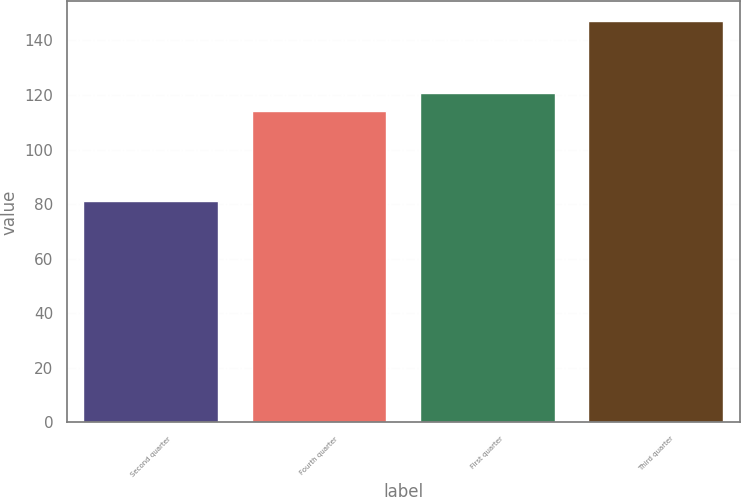<chart> <loc_0><loc_0><loc_500><loc_500><bar_chart><fcel>Second quarter<fcel>Fourth quarter<fcel>First quarter<fcel>Third quarter<nl><fcel>81<fcel>114<fcel>120.6<fcel>147<nl></chart> 